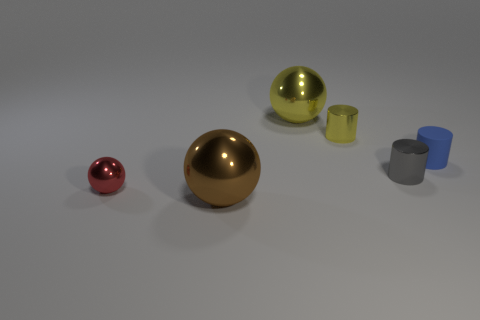Does the red thing have the same shape as the gray object?
Your answer should be compact. No. There is a ball on the left side of the large ball that is to the left of the shiny sphere behind the tiny ball; what is its size?
Make the answer very short. Small. How many other objects are there of the same material as the yellow sphere?
Offer a very short reply. 4. What is the color of the big thing in front of the yellow shiny sphere?
Your answer should be compact. Brown. What material is the big thing in front of the metal ball to the left of the big ball that is in front of the tiny gray metal cylinder?
Keep it short and to the point. Metal. Are there any other objects of the same shape as the red shiny thing?
Make the answer very short. Yes. What is the shape of the yellow object that is the same size as the blue cylinder?
Offer a very short reply. Cylinder. How many metallic things are both behind the big brown object and in front of the gray cylinder?
Offer a terse response. 1. Is the number of tiny things behind the red metal thing less than the number of small blue cylinders?
Provide a short and direct response. No. Is there a gray metal sphere of the same size as the red thing?
Your answer should be compact. No. 